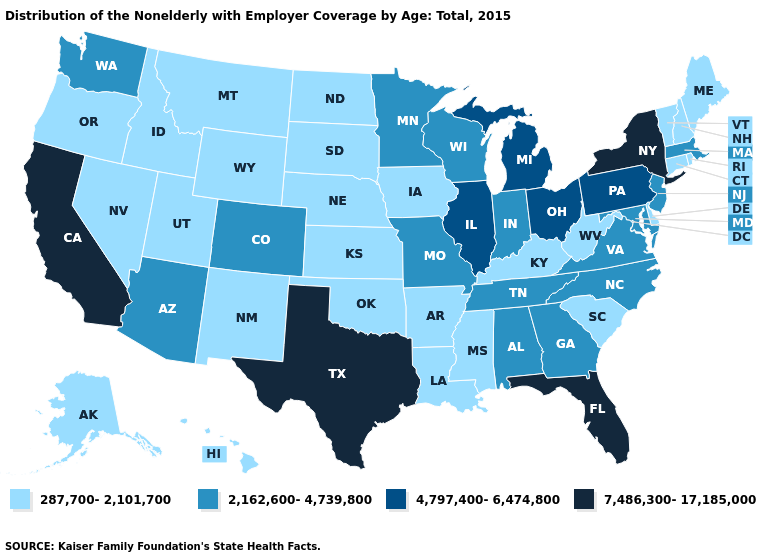How many symbols are there in the legend?
Keep it brief. 4. What is the value of Nevada?
Give a very brief answer. 287,700-2,101,700. What is the value of Arizona?
Keep it brief. 2,162,600-4,739,800. Which states hav the highest value in the MidWest?
Short answer required. Illinois, Michigan, Ohio. What is the value of Delaware?
Give a very brief answer. 287,700-2,101,700. What is the value of Maine?
Short answer required. 287,700-2,101,700. What is the value of New Mexico?
Write a very short answer. 287,700-2,101,700. What is the highest value in the USA?
Be succinct. 7,486,300-17,185,000. Name the states that have a value in the range 7,486,300-17,185,000?
Answer briefly. California, Florida, New York, Texas. Name the states that have a value in the range 2,162,600-4,739,800?
Be succinct. Alabama, Arizona, Colorado, Georgia, Indiana, Maryland, Massachusetts, Minnesota, Missouri, New Jersey, North Carolina, Tennessee, Virginia, Washington, Wisconsin. What is the value of California?
Write a very short answer. 7,486,300-17,185,000. Does New York have the highest value in the Northeast?
Write a very short answer. Yes. Does the first symbol in the legend represent the smallest category?
Be succinct. Yes. Among the states that border New York , does Connecticut have the lowest value?
Quick response, please. Yes. What is the value of North Dakota?
Short answer required. 287,700-2,101,700. 